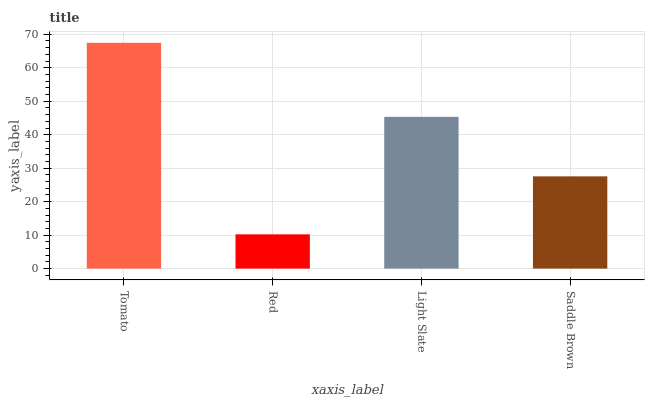Is Light Slate the minimum?
Answer yes or no. No. Is Light Slate the maximum?
Answer yes or no. No. Is Light Slate greater than Red?
Answer yes or no. Yes. Is Red less than Light Slate?
Answer yes or no. Yes. Is Red greater than Light Slate?
Answer yes or no. No. Is Light Slate less than Red?
Answer yes or no. No. Is Light Slate the high median?
Answer yes or no. Yes. Is Saddle Brown the low median?
Answer yes or no. Yes. Is Red the high median?
Answer yes or no. No. Is Light Slate the low median?
Answer yes or no. No. 